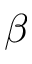<formula> <loc_0><loc_0><loc_500><loc_500>\beta</formula> 